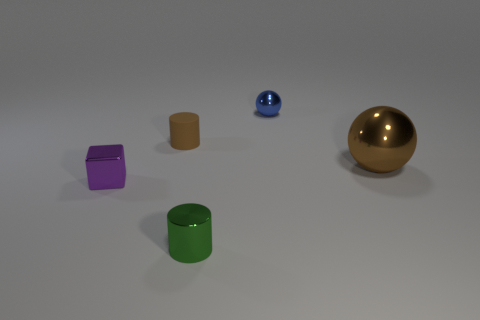Add 2 blue balls. How many objects exist? 7 Subtract all spheres. How many objects are left? 3 Add 5 rubber cylinders. How many rubber cylinders exist? 6 Subtract 0 yellow cylinders. How many objects are left? 5 Subtract all purple things. Subtract all big brown cylinders. How many objects are left? 4 Add 1 brown objects. How many brown objects are left? 3 